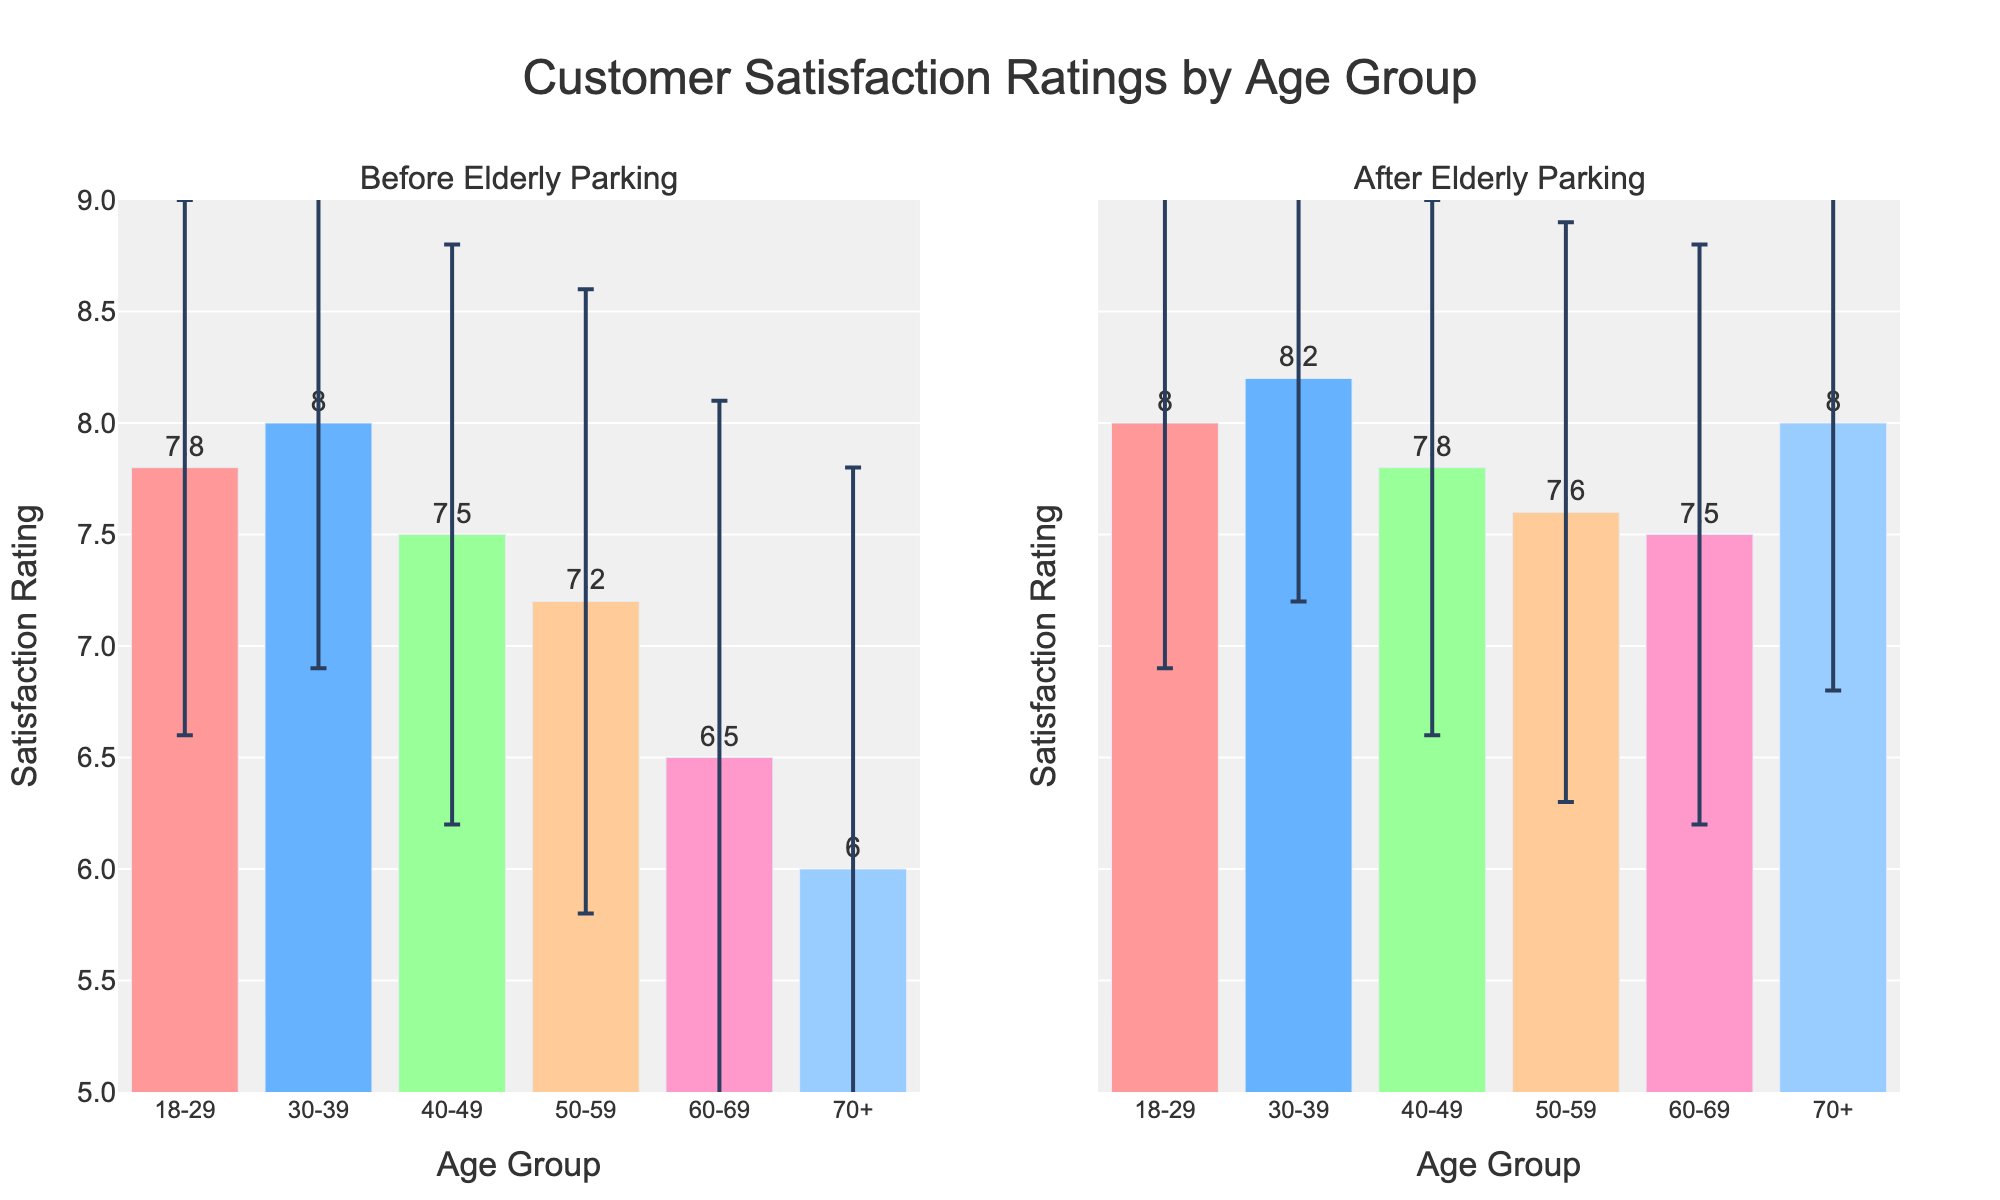What's the title of the figure? The title is displayed at the top center of the figure. It provides an overview of what the figure represents.
Answer: Customer Satisfaction Ratings by Age Group Which age groups experienced an improvement in satisfaction ratings after adding elderly parking? By comparing the bars in the "Before" and "After" subplots for each age group, we see improvements for all age groups as the "After" bars are higher than the "Before" bars.
Answer: All age groups What is the satisfaction rating of the 70+ age group after adding elderly parking? In the "After" subplot, look for the bar representing the 70+ age group and note the value indicated.
Answer: 8.0 Which age group shows the greatest increase in satisfaction rating after adding elderly parking? By calculating the difference between the ratings before and after for each age group, the largest difference is for the 70+ group, changing from 6.0 to 8.0.
Answer: 70+ What is the range of satisfaction ratings before adding elderly parking? The range is determined by subtracting the lowest mean rating (60-69 group: 6.5) from the highest mean rating (30-39 group: 8.0) before elderly parking.
Answer: 6.5 to 8.0 Which age group's satisfaction rating has the highest standard deviation before adding elderly parking? The error bars on the 'Before' ratings reflect the standard deviations. The largest error bar belongs to the 70+ age group with a standard deviation of 1.8.
Answer: 70+ What is the difference in satisfaction ratings for the 50-59 age group before and after adding elderly parking? Subtract the "Before" subplot rating (7.2) from the "After" subplot rating (7.6) for the 50-59 age group.
Answer: 0.4 Did the 40-49 age group notice any change in standard deviation after adding elderly parking? By comparing the height of the error bars in the "Before" and "After" subplots for the 40-49 group, both error bars are roughly equal in size, showing no significant change.
Answer: No What is the average satisfaction rating of all age groups after adding elderly parking? Add all mean ratings from the "After" subplot (8.0 + 8.2 + 7.8 + 7.6 + 7.5 + 8.0 = 47.1) and divide by the number of age groups (6).
Answer: 7.85 How much did the satisfaction rating for the 60-69 age group increase after adding elderly parking? Find the difference between the "After" (7.5) and "Before" (6.5) ratings for the 60-69 group.
Answer: 1.0 